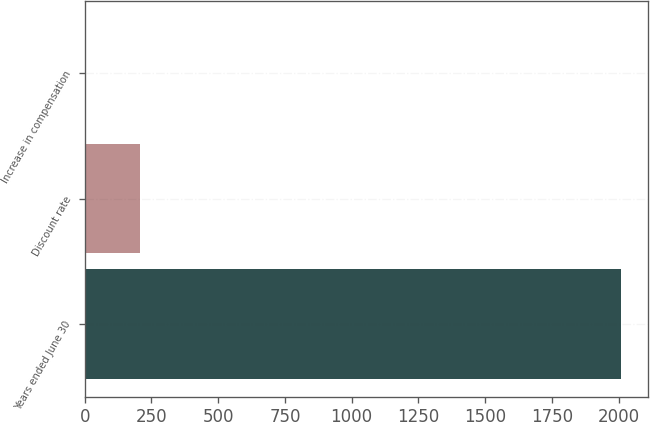<chart> <loc_0><loc_0><loc_500><loc_500><bar_chart><fcel>Years ended June 30<fcel>Discount rate<fcel>Increase in compensation<nl><fcel>2009<fcel>205.85<fcel>5.5<nl></chart> 